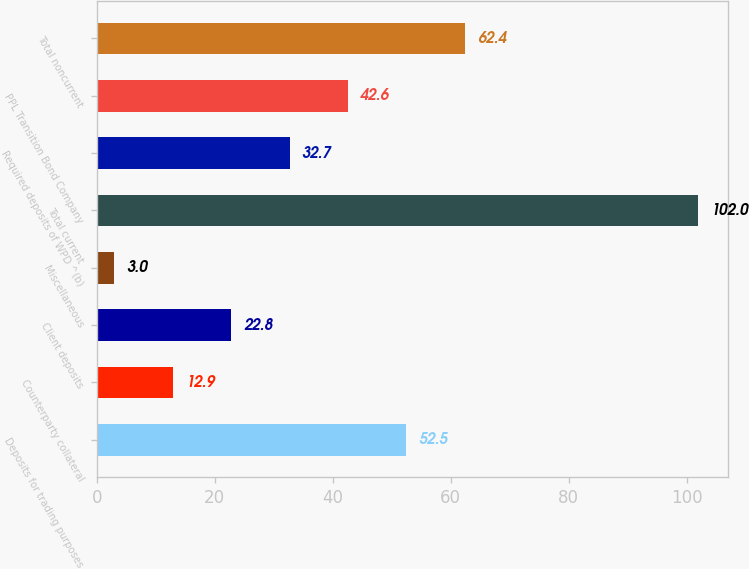Convert chart. <chart><loc_0><loc_0><loc_500><loc_500><bar_chart><fcel>Deposits for trading purposes<fcel>Counterparty collateral<fcel>Client deposits<fcel>Miscellaneous<fcel>Total current<fcel>Required deposits of WPD ^(b)<fcel>PPL Transition Bond Company<fcel>Total noncurrent<nl><fcel>52.5<fcel>12.9<fcel>22.8<fcel>3<fcel>102<fcel>32.7<fcel>42.6<fcel>62.4<nl></chart> 